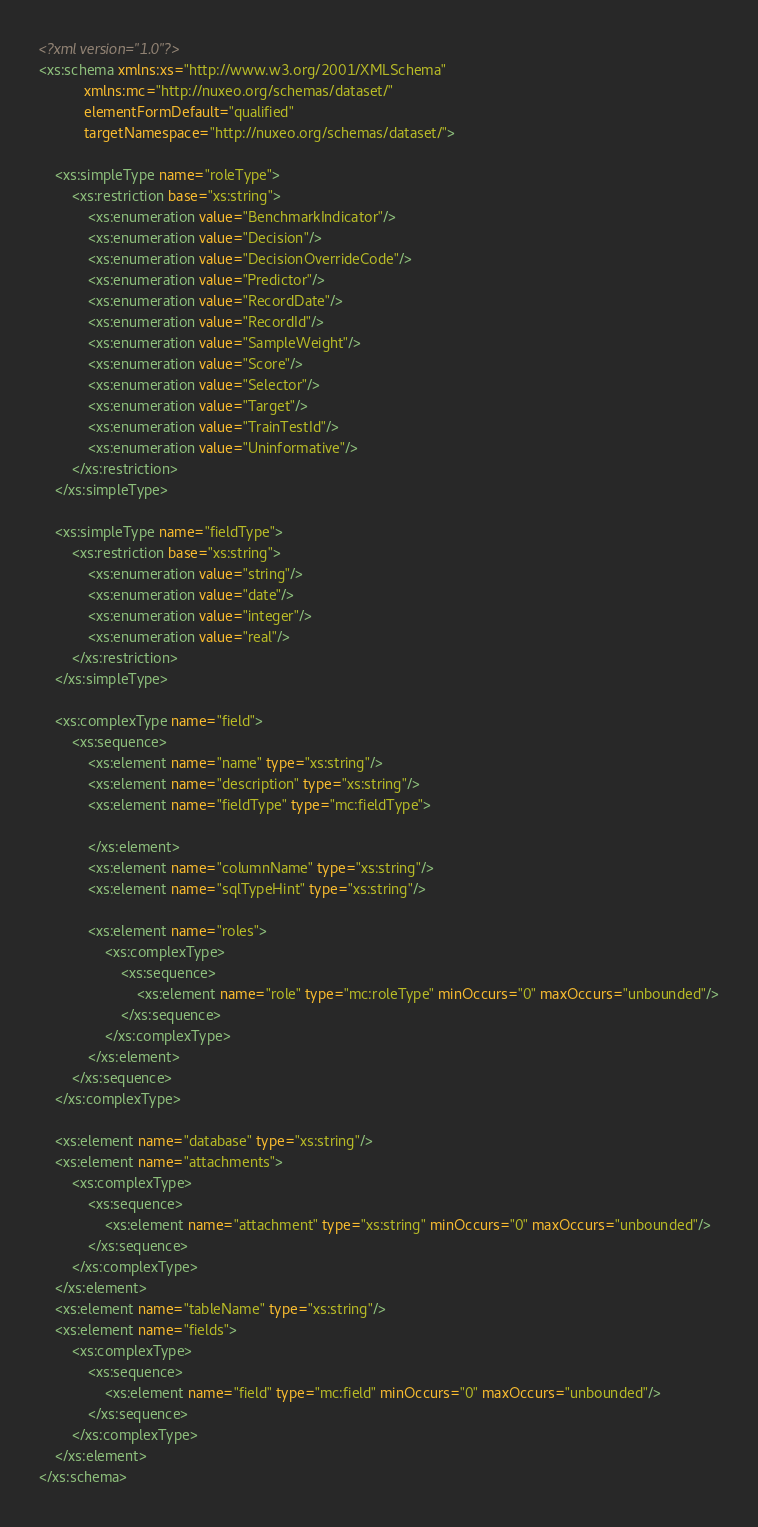Convert code to text. <code><loc_0><loc_0><loc_500><loc_500><_XML_><?xml version="1.0"?>
<xs:schema xmlns:xs="http://www.w3.org/2001/XMLSchema"
           xmlns:mc="http://nuxeo.org/schemas/dataset/"
           elementFormDefault="qualified"
           targetNamespace="http://nuxeo.org/schemas/dataset/">

    <xs:simpleType name="roleType">
        <xs:restriction base="xs:string">
            <xs:enumeration value="BenchmarkIndicator"/>
            <xs:enumeration value="Decision"/>
            <xs:enumeration value="DecisionOverrideCode"/>
            <xs:enumeration value="Predictor"/>
            <xs:enumeration value="RecordDate"/>
            <xs:enumeration value="RecordId"/>
            <xs:enumeration value="SampleWeight"/>
            <xs:enumeration value="Score"/>
            <xs:enumeration value="Selector"/>
            <xs:enumeration value="Target"/>
            <xs:enumeration value="TrainTestId"/>
            <xs:enumeration value="Uninformative"/>
        </xs:restriction>
    </xs:simpleType>

    <xs:simpleType name="fieldType">
        <xs:restriction base="xs:string">
            <xs:enumeration value="string"/>
            <xs:enumeration value="date"/>
            <xs:enumeration value="integer"/>
            <xs:enumeration value="real"/>
        </xs:restriction>
    </xs:simpleType>

    <xs:complexType name="field">
        <xs:sequence>
            <xs:element name="name" type="xs:string"/>
            <xs:element name="description" type="xs:string"/>
            <xs:element name="fieldType" type="mc:fieldType">

            </xs:element>
            <xs:element name="columnName" type="xs:string"/>
            <xs:element name="sqlTypeHint" type="xs:string"/>

            <xs:element name="roles">
                <xs:complexType>
                    <xs:sequence>
                        <xs:element name="role" type="mc:roleType" minOccurs="0" maxOccurs="unbounded"/>
                    </xs:sequence>
                </xs:complexType>
            </xs:element>
        </xs:sequence>
    </xs:complexType>

    <xs:element name="database" type="xs:string"/>
    <xs:element name="attachments">
        <xs:complexType>
            <xs:sequence>
                <xs:element name="attachment" type="xs:string" minOccurs="0" maxOccurs="unbounded"/>
            </xs:sequence>
        </xs:complexType>
    </xs:element>
    <xs:element name="tableName" type="xs:string"/>
    <xs:element name="fields">
        <xs:complexType>
            <xs:sequence>
                <xs:element name="field" type="mc:field" minOccurs="0" maxOccurs="unbounded"/>
            </xs:sequence>
        </xs:complexType>
    </xs:element>
</xs:schema></code> 